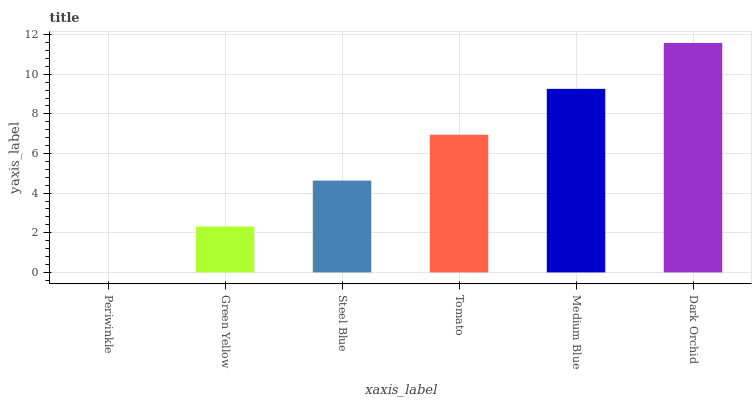Is Periwinkle the minimum?
Answer yes or no. Yes. Is Dark Orchid the maximum?
Answer yes or no. Yes. Is Green Yellow the minimum?
Answer yes or no. No. Is Green Yellow the maximum?
Answer yes or no. No. Is Green Yellow greater than Periwinkle?
Answer yes or no. Yes. Is Periwinkle less than Green Yellow?
Answer yes or no. Yes. Is Periwinkle greater than Green Yellow?
Answer yes or no. No. Is Green Yellow less than Periwinkle?
Answer yes or no. No. Is Tomato the high median?
Answer yes or no. Yes. Is Steel Blue the low median?
Answer yes or no. Yes. Is Green Yellow the high median?
Answer yes or no. No. Is Dark Orchid the low median?
Answer yes or no. No. 